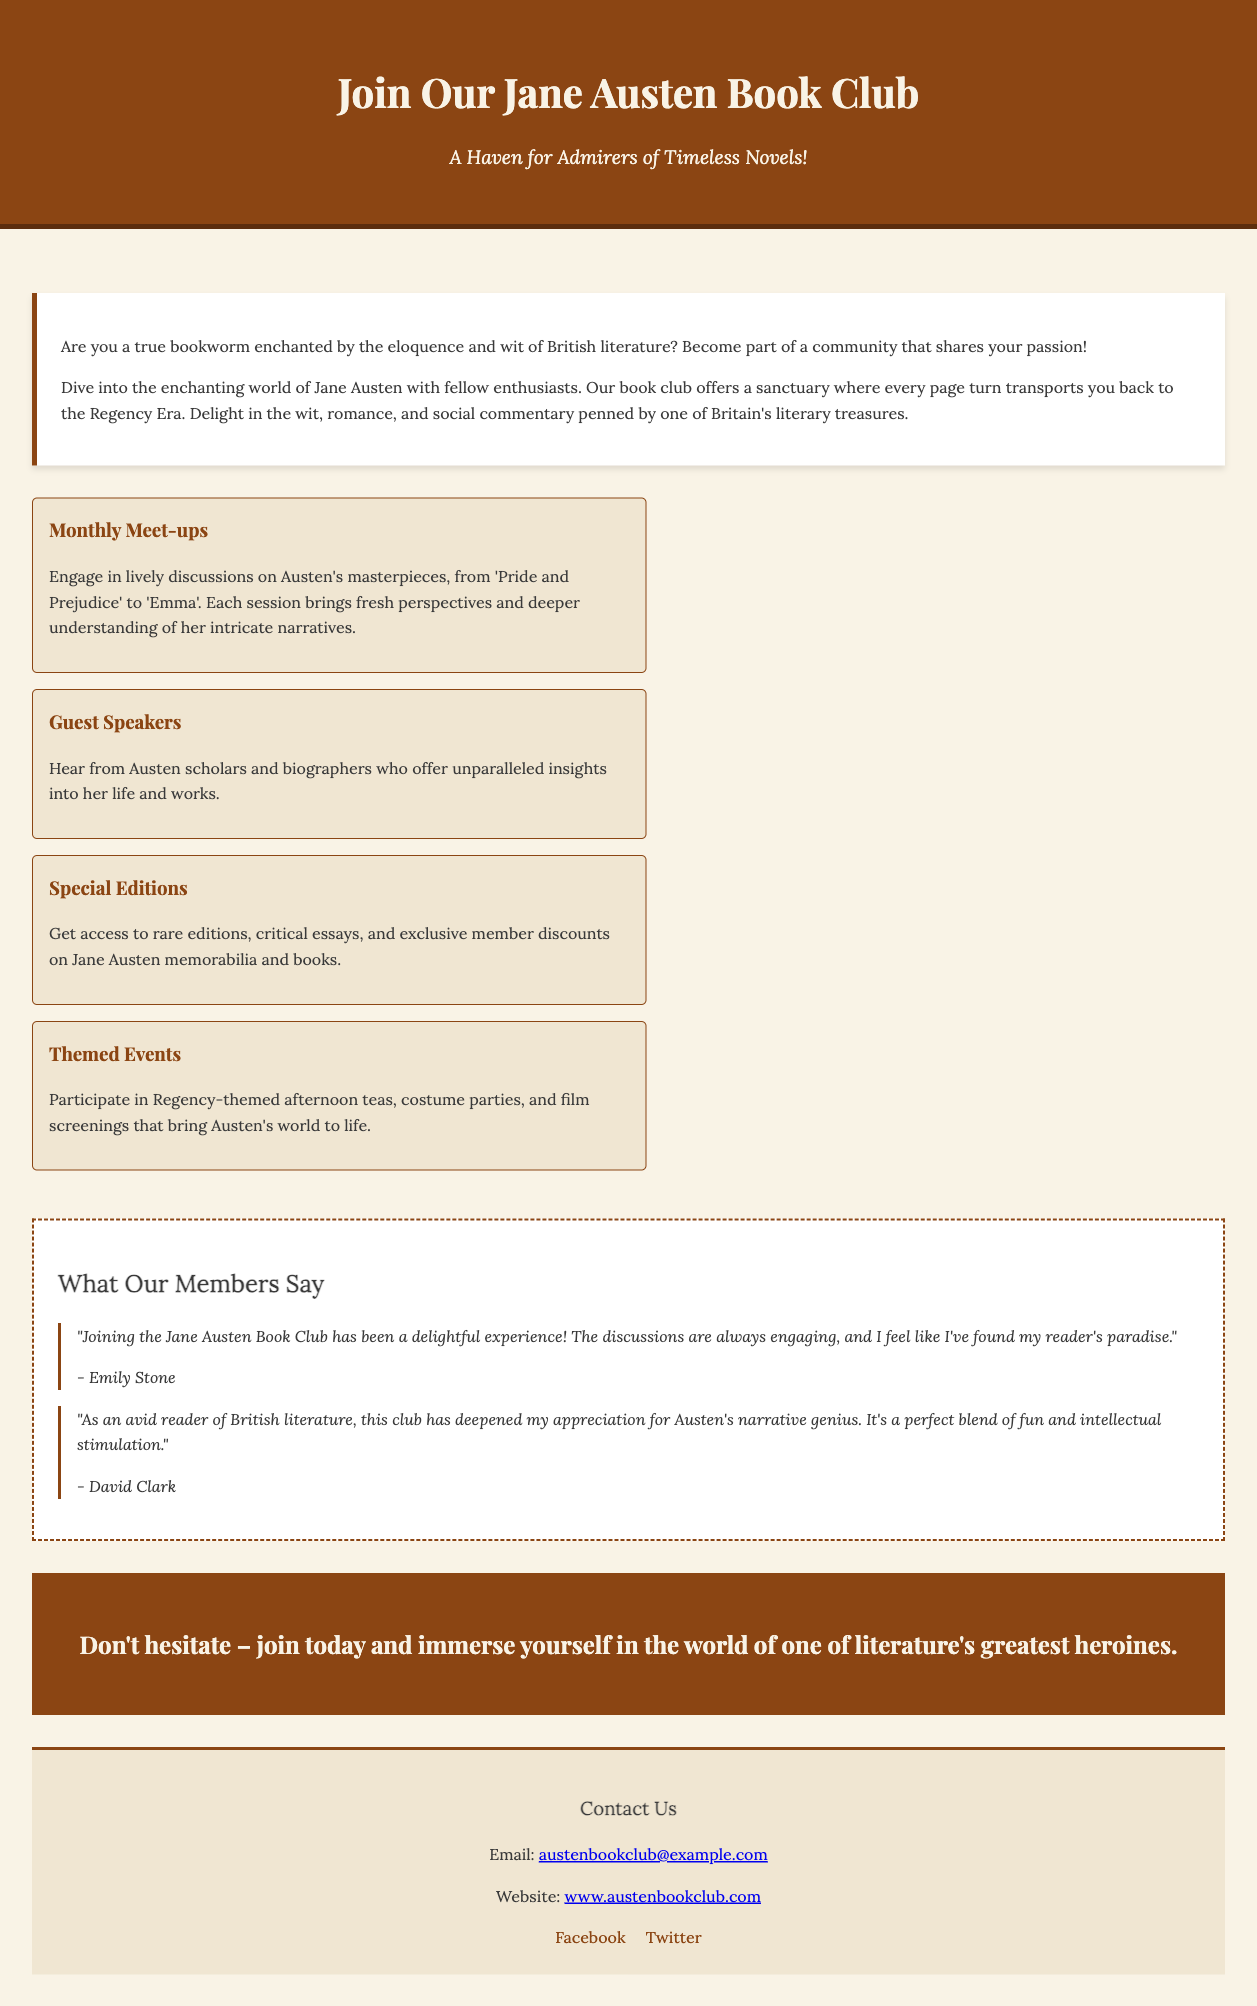What is the title of the book club? The title of the book club is clearly stated at the top of the advertisement.
Answer: Join Our Jane Austen Book Club What is the tagline of the book club? The tagline serves as a descriptor and is listed directly below the title.
Answer: A Haven for Admirers of Timeless Novels! How often are the meet-ups held? The frequency of the meet-ups is implied in the section titled “Monthly Meet-ups.”
Answer: Monthly What are the themed events mentioned? The themed events are specified within the highlights section, showcasing various activities.
Answer: Regency-themed afternoon teas, costume parties, and film screenings Who is Emily Stone? Emily Stone is mentioned in the testimonials section, providing a personal opinion about the book club.
Answer: A member What type of events can members participate in? This is highlighted under the special features of the book club, showing member engagement.
Answer: Themed Events What kind of speakers are invited? The document highlights the type of speakers that contribute to the book club meetings.
Answer: Guest Speakers What is the contact email for the book club? The contact email is provided in the contact information section for inquiries.
Answer: austenbookclub@example.com How does the book club describe Jane Austen's writing? The description emphasizes the qualities of Austen's novels as shared in the introduction.
Answer: Eloquence and wit of British literature 